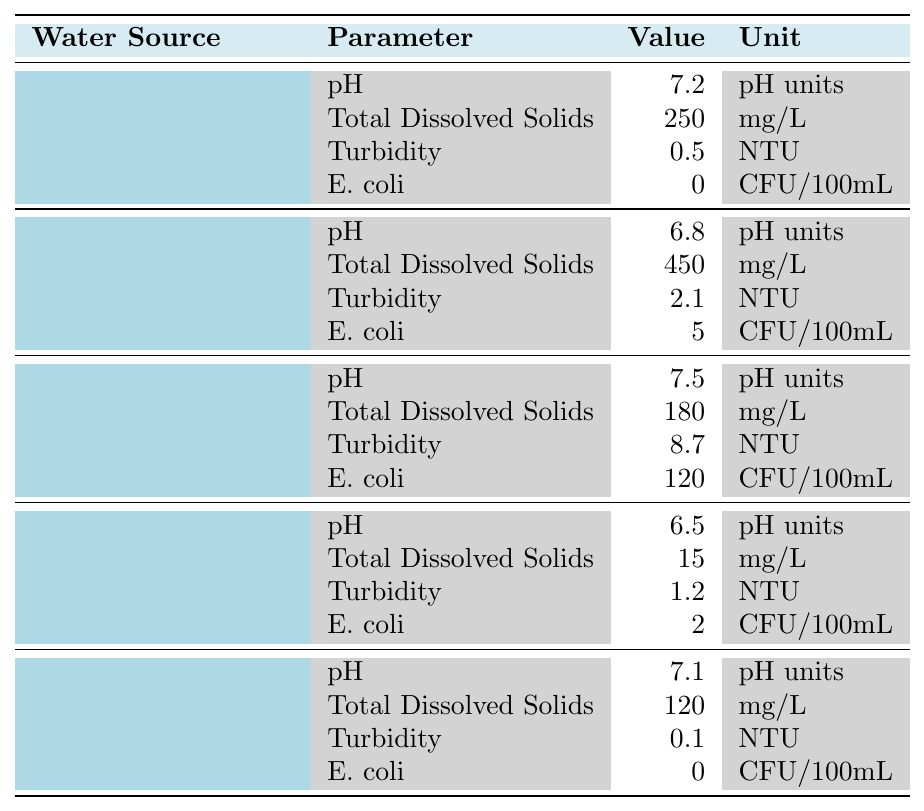What is the pH value of River Water? The table lists the pH value for each water source. For River Water, the value is stated as 7.5 in the table.
Answer: 7.5 Which water source has the highest Total Dissolved Solids? The values for Total Dissolved Solids are provided for each water source. By comparing them, Community Well has the highest value at 450 mg/L.
Answer: Community Well Is the turbidity of Bottled Water lower than that of Rainwater Harvesting? According to the table, Bottled Water has a turbidity of 0.1 NTU, while Rainwater Harvesting has 1.2 NTU. Since 0.1 is less than 1.2, the statement is true.
Answer: Yes What is the average E. coli level across all water sources? The E. coli levels are: 0 (Municipal Tap Water), 5 (Community Well), 120 (River Water), 2 (Rainwater Harvesting), and 0 (Bottled Water). The total is 127, and there are 5 sources, so average is 127/5 = 25.4.
Answer: 25.4 Which water source has both the lowest pH and the lowest Total Dissolved Solids? The lowest pH in the table is 6.5 from Rainwater Harvesting. The lowest Total Dissolved Solids is 15 mg/L, also from Rainwater Harvesting. Since both values come from Rainwater Harvesting, it meets both criteria.
Answer: Rainwater Harvesting What is the difference in turbidity between River Water and Community Well? River Water has a turbidity of 8.7 NTU and Community Well has 2.1 NTU. The difference is calculated as 8.7 - 2.1 = 6.6 NTU.
Answer: 6.6 NTU Is there any water source listed that has 0 E. coli? The table indicates that both Municipal Tap Water and Bottled Water report an E. coli value of 0. Therefore, the answer is yes.
Answer: Yes Which water source has the highest pH value and how much higher is it compared to Bottled Water? The highest pH value is from River Water at 7.5; Bottled Water has a pH of 7.1. The difference is 7.5 - 7.1 = 0.4.
Answer: 0.4 What is the average Total Dissolved Solids for Municipal Tap Water and Bottled Water? Total Dissolved Solids for Municipal Tap Water is 250 mg/L and for Bottled Water, it is 120 mg/L. The average is (250 + 120) / 2 = 185 mg/L.
Answer: 185 mg/L Which water source has a turbidity value above 5 NTU? Reviewing the turbidity values, River Water has a turbidity of 8.7 NTU, which is above 5 NTU. None of the other sources exceed this value.
Answer: River Water How many water sources have a pH value lower than 7? The sources with pH lower than 7 are Community Well (6.8) and Rainwater Harvesting (6.5). Therefore, there are 2 such sources.
Answer: 2 